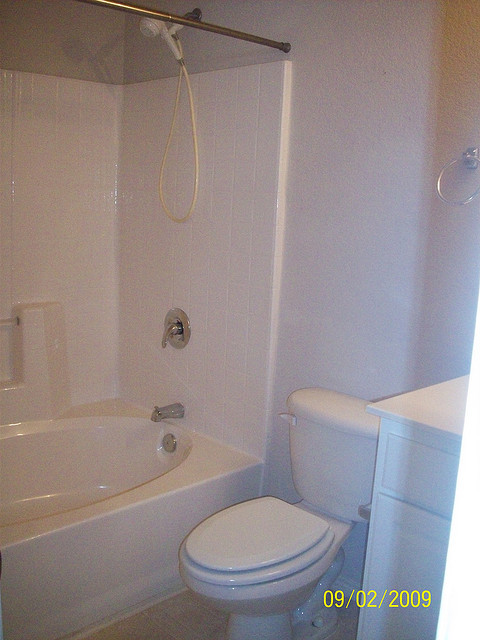<image>Is there a mirror in the room? There is no mirror in the room. Is there a mirror in the room? There is no mirror in the room. 